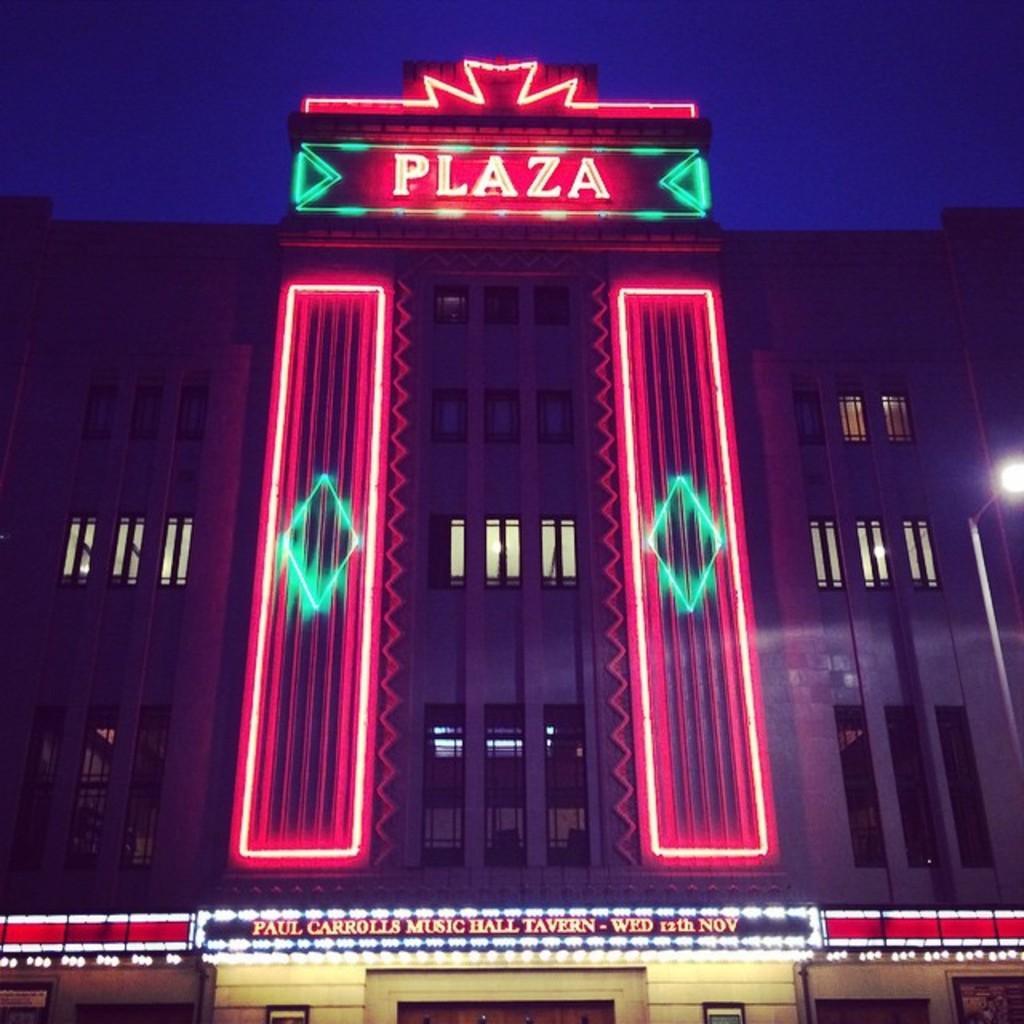Could you give a brief overview of what you see in this image? In the foreground I can see a building and windows. On the top I can see the blue sky. This image is taken during night. 